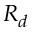Convert formula to latex. <formula><loc_0><loc_0><loc_500><loc_500>R _ { d }</formula> 